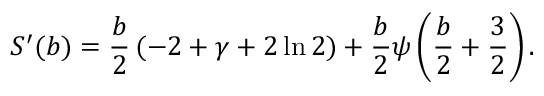<formula> <loc_0><loc_0><loc_500><loc_500>S ^ { \prime } ( b ) = \frac { b } { 2 } \, ( - 2 + \gamma + 2 \ln 2 ) + \frac { b } { 2 } \psi \left ( \frac { b } { 2 } + \frac { 3 } { 2 } \right ) .</formula> 